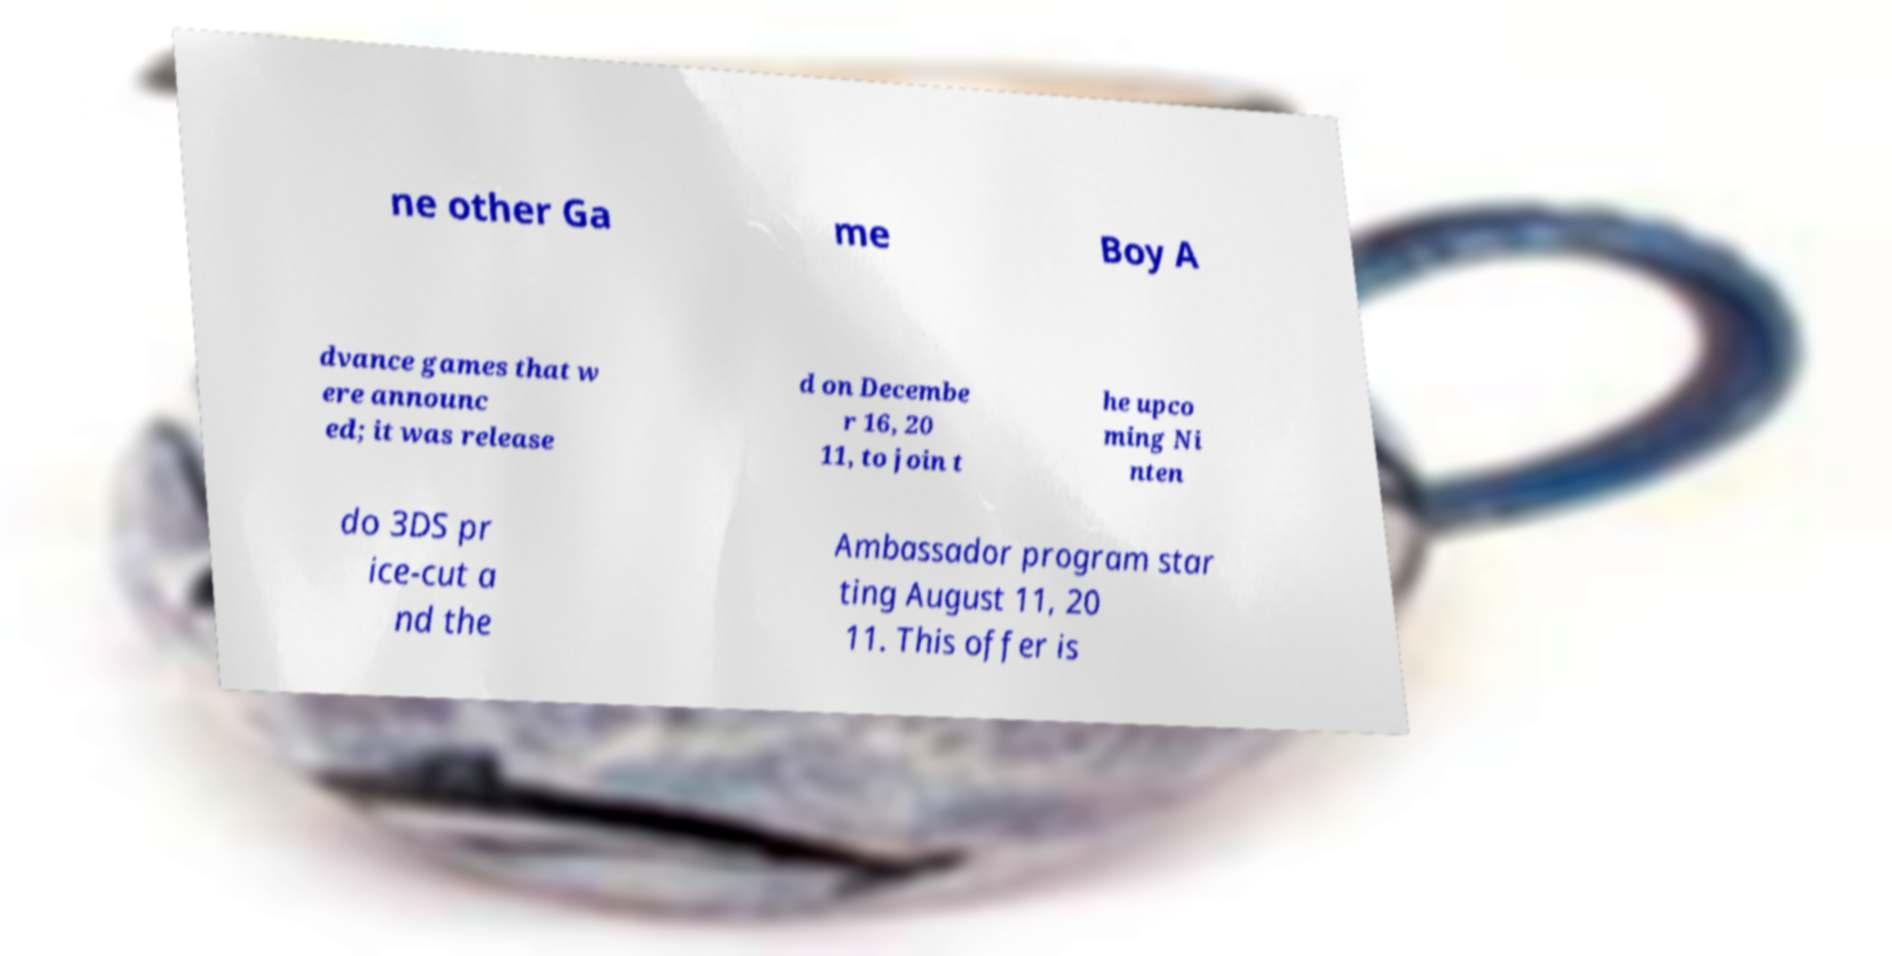What messages or text are displayed in this image? I need them in a readable, typed format. ne other Ga me Boy A dvance games that w ere announc ed; it was release d on Decembe r 16, 20 11, to join t he upco ming Ni nten do 3DS pr ice-cut a nd the Ambassador program star ting August 11, 20 11. This offer is 